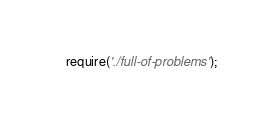<code> <loc_0><loc_0><loc_500><loc_500><_JavaScript_>require('./full-of-problems');</code> 